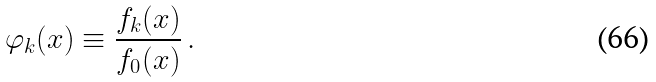<formula> <loc_0><loc_0><loc_500><loc_500>\varphi _ { k } ( x ) \equiv \frac { f _ { k } ( x ) } { f _ { 0 } ( x ) } \, .</formula> 